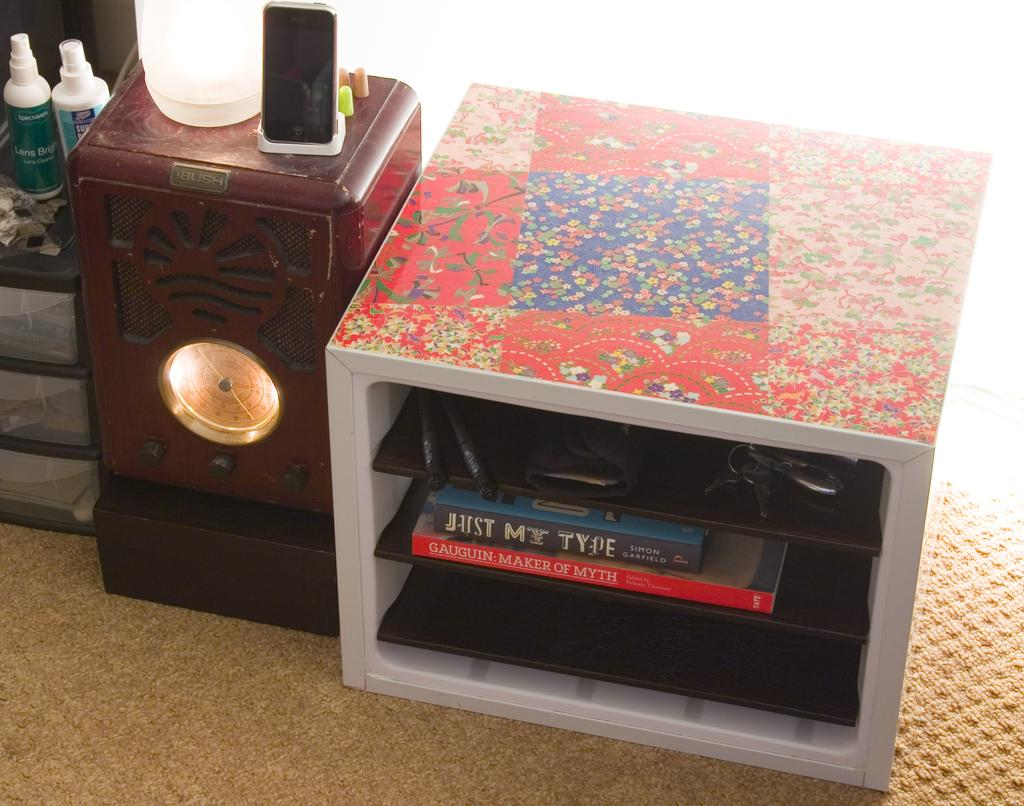<image>
Present a compact description of the photo's key features. A small bookshelf with the book Just My type sits to the right of a clock. 